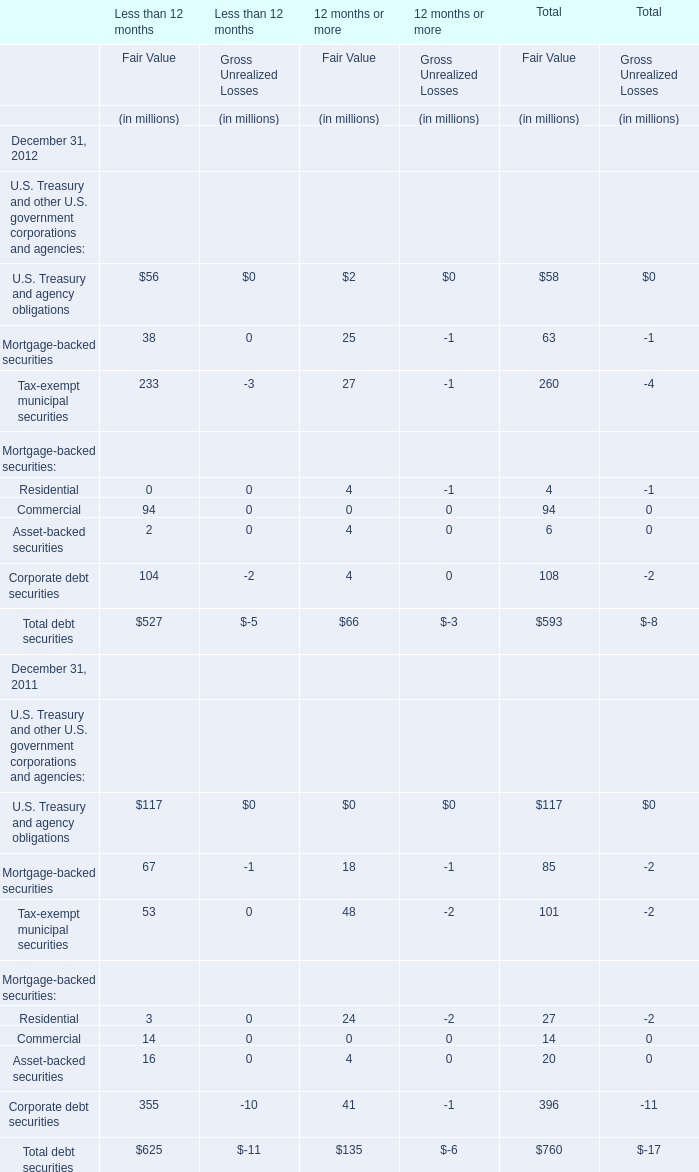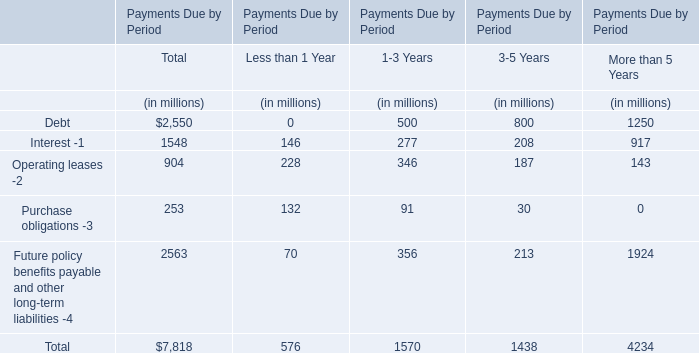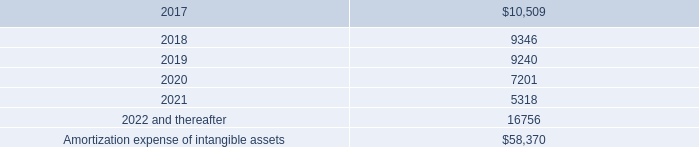what is the percentage change in interest expense from 2015 to 2016? 
Computations: ((13.0 - 13.9) / 13.9)
Answer: -0.06475. 